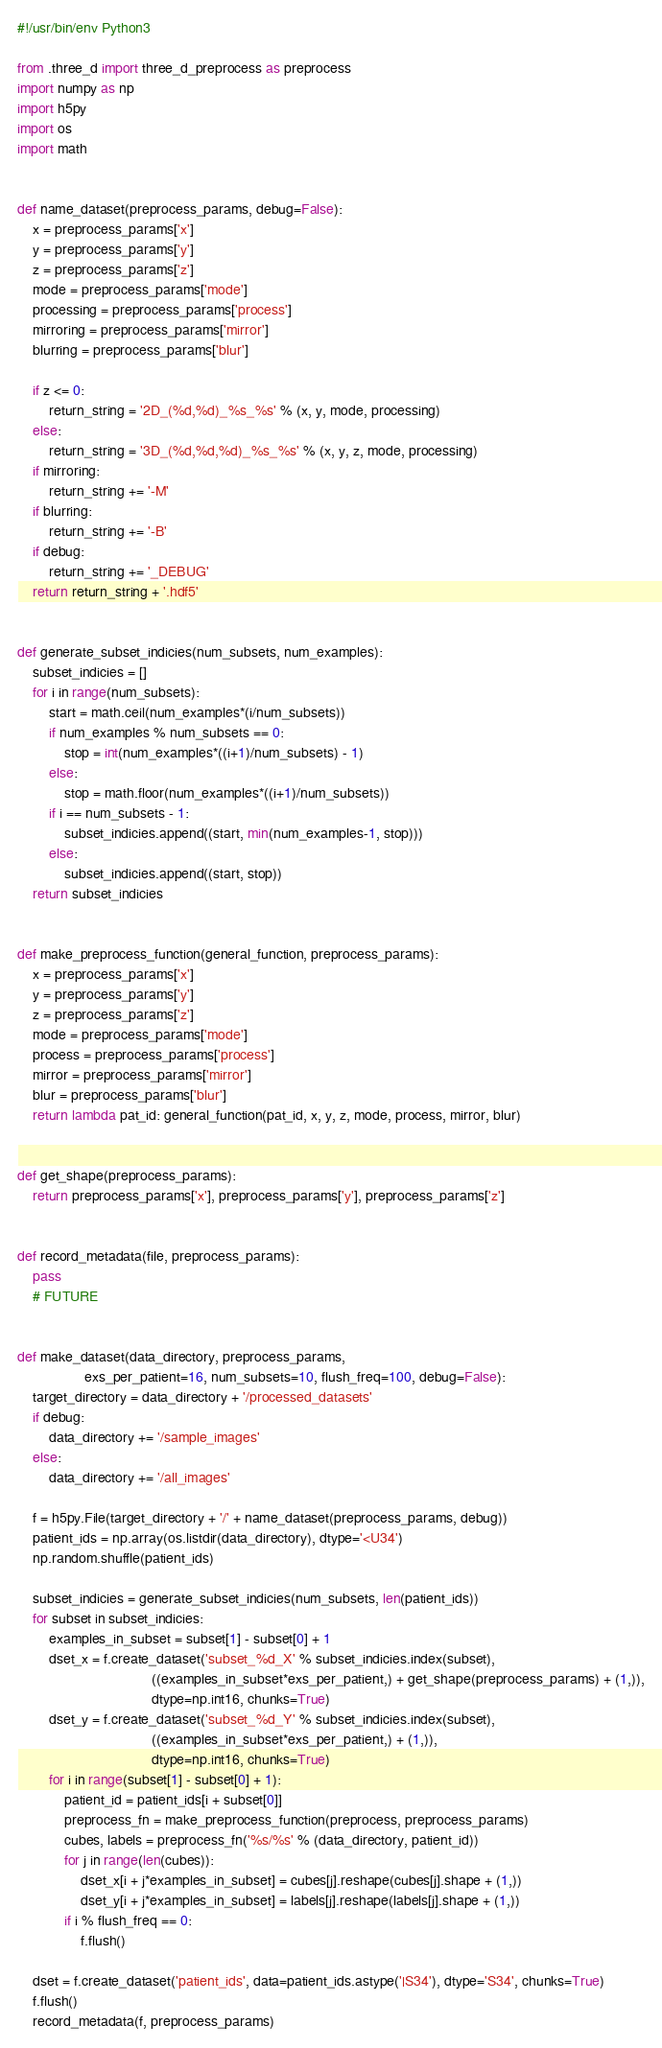<code> <loc_0><loc_0><loc_500><loc_500><_Python_>#!/usr/bin/env Python3

from .three_d import three_d_preprocess as preprocess
import numpy as np
import h5py
import os
import math


def name_dataset(preprocess_params, debug=False):
    x = preprocess_params['x']
    y = preprocess_params['y']
    z = preprocess_params['z']
    mode = preprocess_params['mode']
    processing = preprocess_params['process']
    mirroring = preprocess_params['mirror']
    blurring = preprocess_params['blur']

    if z <= 0:
        return_string = '2D_(%d,%d)_%s_%s' % (x, y, mode, processing)
    else:
        return_string = '3D_(%d,%d,%d)_%s_%s' % (x, y, z, mode, processing)
    if mirroring:
        return_string += '-M'
    if blurring:
        return_string += '-B'
    if debug:
        return_string += '_DEBUG'
    return return_string + '.hdf5'


def generate_subset_indicies(num_subsets, num_examples):
    subset_indicies = []
    for i in range(num_subsets):
        start = math.ceil(num_examples*(i/num_subsets))
        if num_examples % num_subsets == 0:
            stop = int(num_examples*((i+1)/num_subsets) - 1)
        else:
            stop = math.floor(num_examples*((i+1)/num_subsets))
        if i == num_subsets - 1:
            subset_indicies.append((start, min(num_examples-1, stop)))
        else:
            subset_indicies.append((start, stop))
    return subset_indicies


def make_preprocess_function(general_function, preprocess_params):
    x = preprocess_params['x']
    y = preprocess_params['y']
    z = preprocess_params['z']
    mode = preprocess_params['mode']
    process = preprocess_params['process']
    mirror = preprocess_params['mirror']
    blur = preprocess_params['blur']
    return lambda pat_id: general_function(pat_id, x, y, z, mode, process, mirror, blur)


def get_shape(preprocess_params):
    return preprocess_params['x'], preprocess_params['y'], preprocess_params['z']


def record_metadata(file, preprocess_params):
    pass
    # FUTURE


def make_dataset(data_directory, preprocess_params,
                 exs_per_patient=16, num_subsets=10, flush_freq=100, debug=False):
    target_directory = data_directory + '/processed_datasets'
    if debug:
        data_directory += '/sample_images'
    else:
        data_directory += '/all_images'

    f = h5py.File(target_directory + '/' + name_dataset(preprocess_params, debug))
    patient_ids = np.array(os.listdir(data_directory), dtype='<U34')
    np.random.shuffle(patient_ids)

    subset_indicies = generate_subset_indicies(num_subsets, len(patient_ids))
    for subset in subset_indicies:
        examples_in_subset = subset[1] - subset[0] + 1
        dset_x = f.create_dataset('subset_%d_X' % subset_indicies.index(subset),
                                  ((examples_in_subset*exs_per_patient,) + get_shape(preprocess_params) + (1,)),
                                  dtype=np.int16, chunks=True)
        dset_y = f.create_dataset('subset_%d_Y' % subset_indicies.index(subset),
                                  ((examples_in_subset*exs_per_patient,) + (1,)),
                                  dtype=np.int16, chunks=True)
        for i in range(subset[1] - subset[0] + 1):
            patient_id = patient_ids[i + subset[0]]
            preprocess_fn = make_preprocess_function(preprocess, preprocess_params)
            cubes, labels = preprocess_fn('%s/%s' % (data_directory, patient_id))
            for j in range(len(cubes)):
                dset_x[i + j*examples_in_subset] = cubes[j].reshape(cubes[j].shape + (1,))
                dset_y[i + j*examples_in_subset] = labels[j].reshape(labels[j].shape + (1,))
            if i % flush_freq == 0:
                f.flush()

    dset = f.create_dataset('patient_ids', data=patient_ids.astype('|S34'), dtype='S34', chunks=True)
    f.flush()
    record_metadata(f, preprocess_params)</code> 